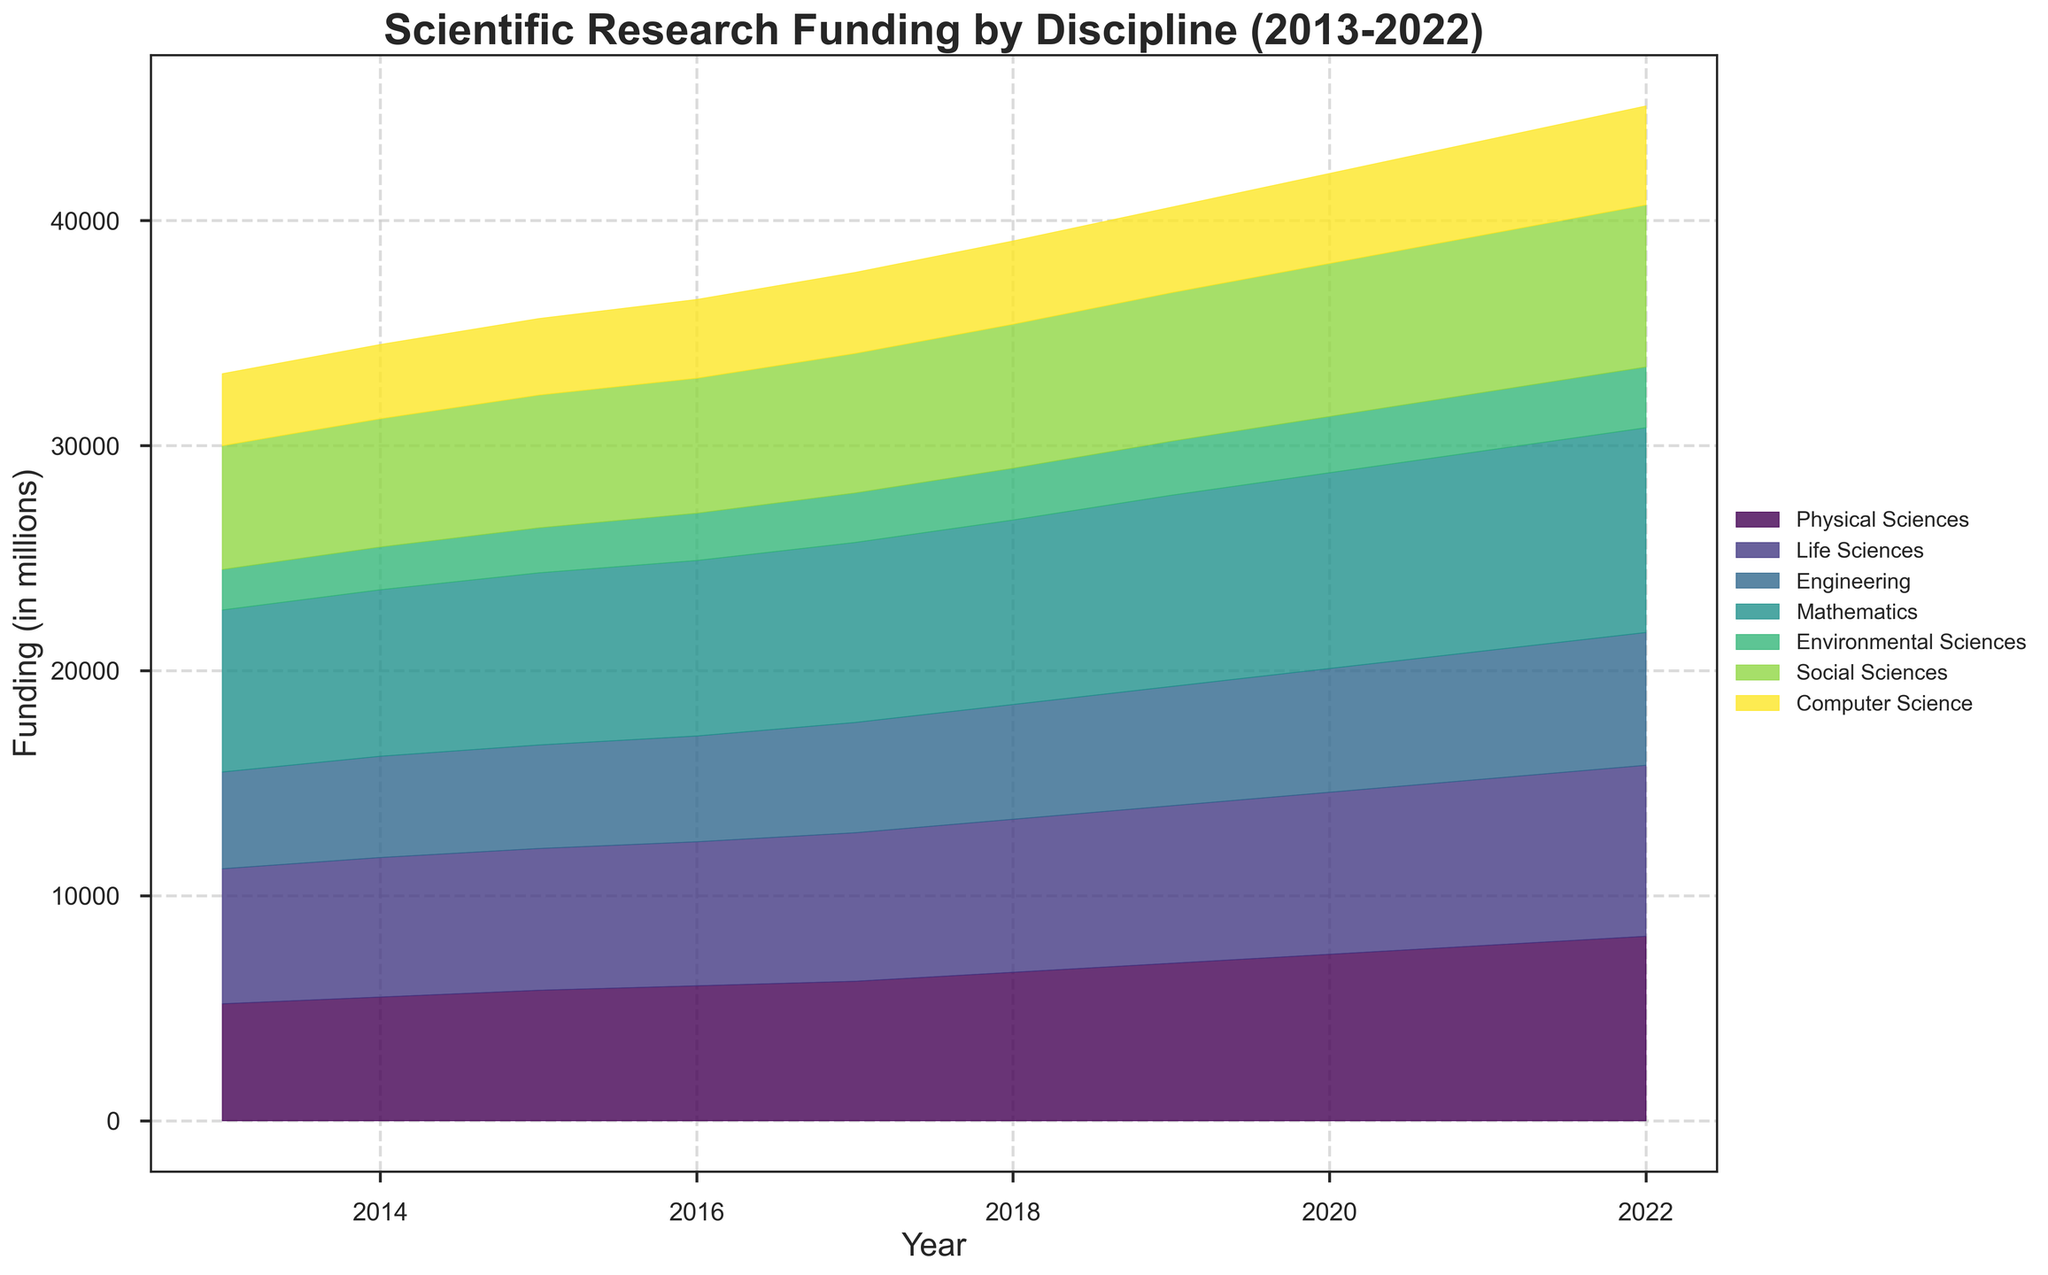What's the title of the figure? The title is typically found at the top of the figure and provides an overview of the visualized data. In this case, it mentions "Scientific Research Funding by Discipline (2013-2022)".
Answer: Scientific Research Funding by Discipline (2013-2022) What is the total funding for Physical Sciences in 2020? Locate the area representing Physical Sciences and observe the value along the vertical axis for the year 2020.
Answer: 6800 Which discipline received the highest funding in 2022? Compare the top edges of all disciplines at the year 2022. The Life Sciences has the highest vertical extent.
Answer: Life Sciences How has the funding for Mathematics changed from 2013 to 2022? Observe the area representing Mathematics. Note the values at the beginning (2013) and end (2022) of the timeline and compare them.
Answer: Increased from 1800 to 2700 Which two disciplines had nearly equal funding in 2018? Compare the height of the filled areas for each discipline in 2018. Identify areas with similar heights.
Answer: Physical Sciences and Environmental Sciences What is the approximate total funding for all disciplines combined in 2015? Sum the vertical extents of all disciplines at the year 2015. Add up the midpoints of streamed areas for each discipline at this year.
Answer: Approximately 35650 Between which years did Environmental Sciences see the greatest increase in funding? Examine the stream representing Environmental Sciences and identify the years between which the increase in height is the most significant.
Answer: 2013 to 2014 How does the funding trend for Engineering compare to that for Social Sciences over the decade? Observe how the streams for Engineering and Social Sciences change year by year from 2013 to 2022. Engineering shows a larger and steadier increase.
Answer: Engineering increases more steadily and by a larger magnitude than Social Sciences What is the average annual funding for Computer Science over the decade? Sum the annual funding values for Computer Science from 2013 to 2022, then divide by the number of years (10).
Answer: 6370 